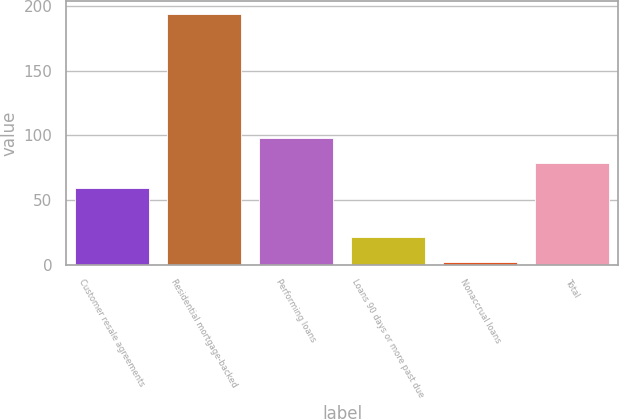Convert chart. <chart><loc_0><loc_0><loc_500><loc_500><bar_chart><fcel>Customer resale agreements<fcel>Residential mortgage-backed<fcel>Performing loans<fcel>Loans 90 days or more past due<fcel>Nonaccrual loans<fcel>Total<nl><fcel>59.6<fcel>194<fcel>98<fcel>21.2<fcel>2<fcel>78.8<nl></chart> 